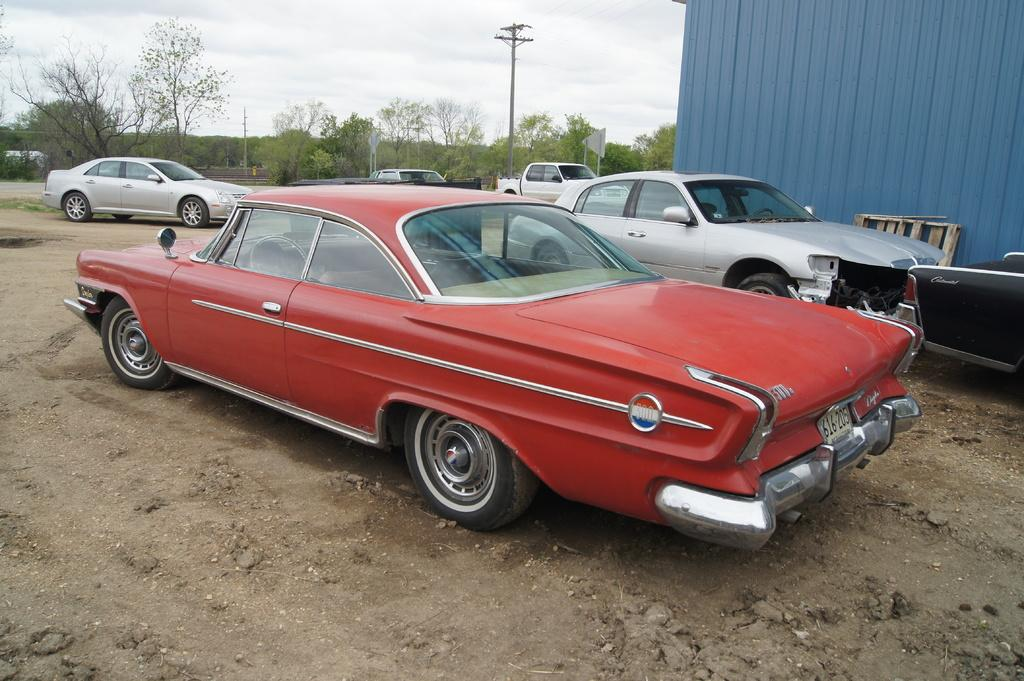What types of vehicles can be seen in the image? There are many vehicles of different colors in the image. What natural elements are present in the image? There are trees, grass, and sand in the image. What man-made structures can be seen in the image? There are poles and a shed in the image. What is visible in the background of the image? The sky is visible in the image. Can you tell me how many clovers are growing in the image? There is no mention of clovers in the image, so it is not possible to determine their presence or quantity. 